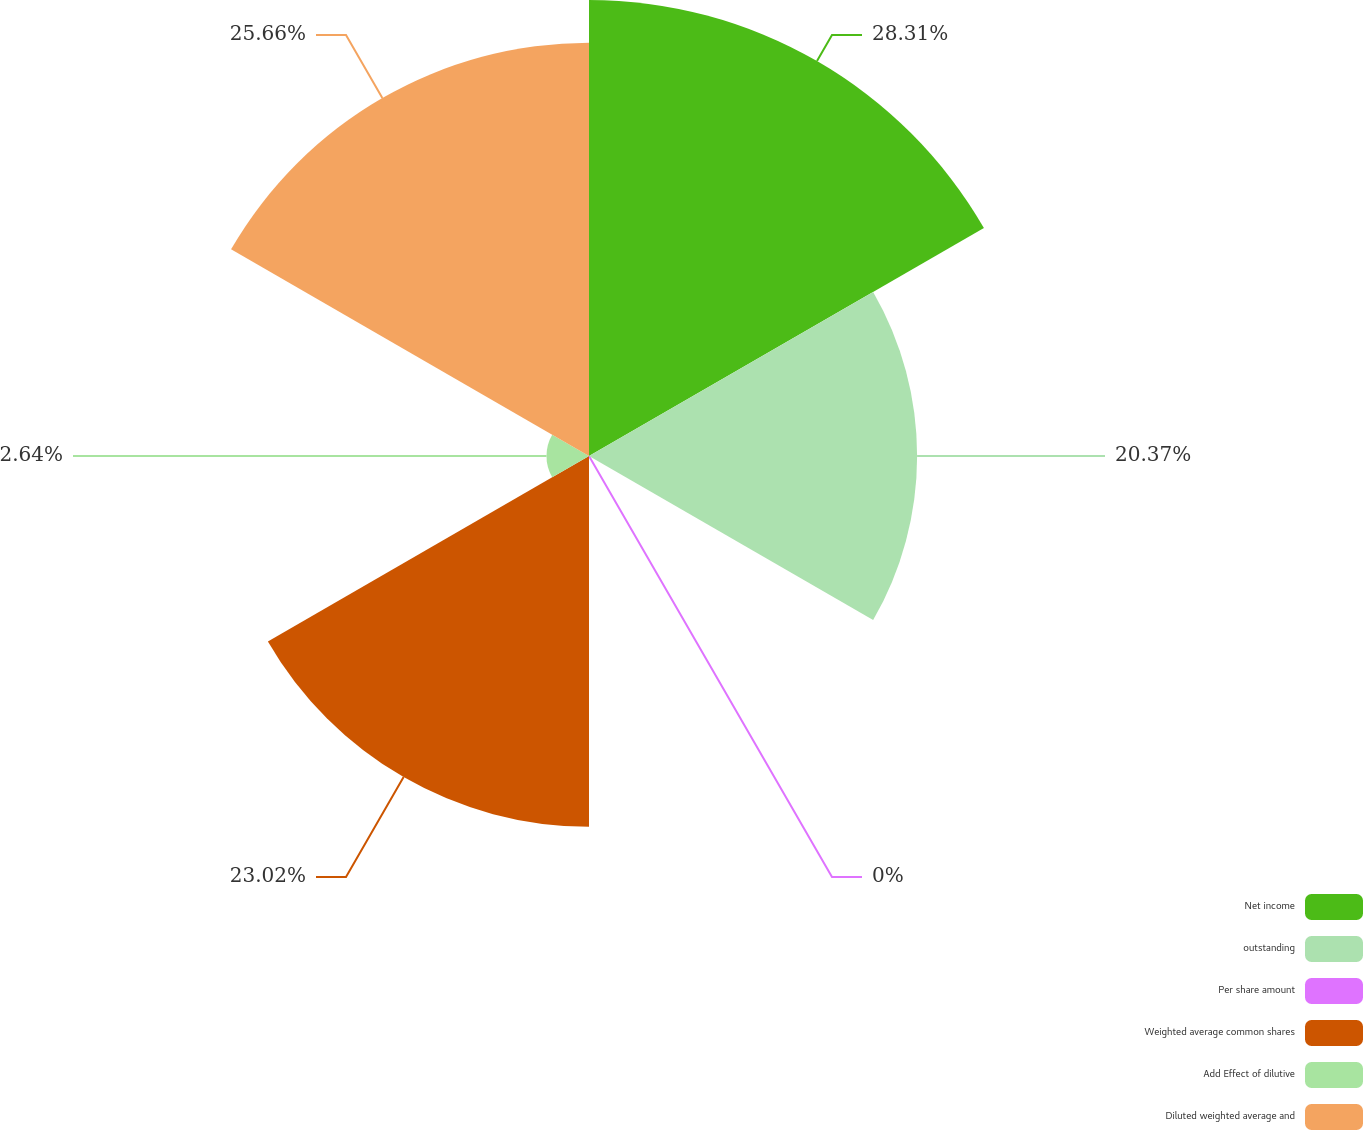Convert chart to OTSL. <chart><loc_0><loc_0><loc_500><loc_500><pie_chart><fcel>Net income<fcel>outstanding<fcel>Per share amount<fcel>Weighted average common shares<fcel>Add Effect of dilutive<fcel>Diluted weighted average and<nl><fcel>28.31%<fcel>20.37%<fcel>0.0%<fcel>23.02%<fcel>2.64%<fcel>25.66%<nl></chart> 